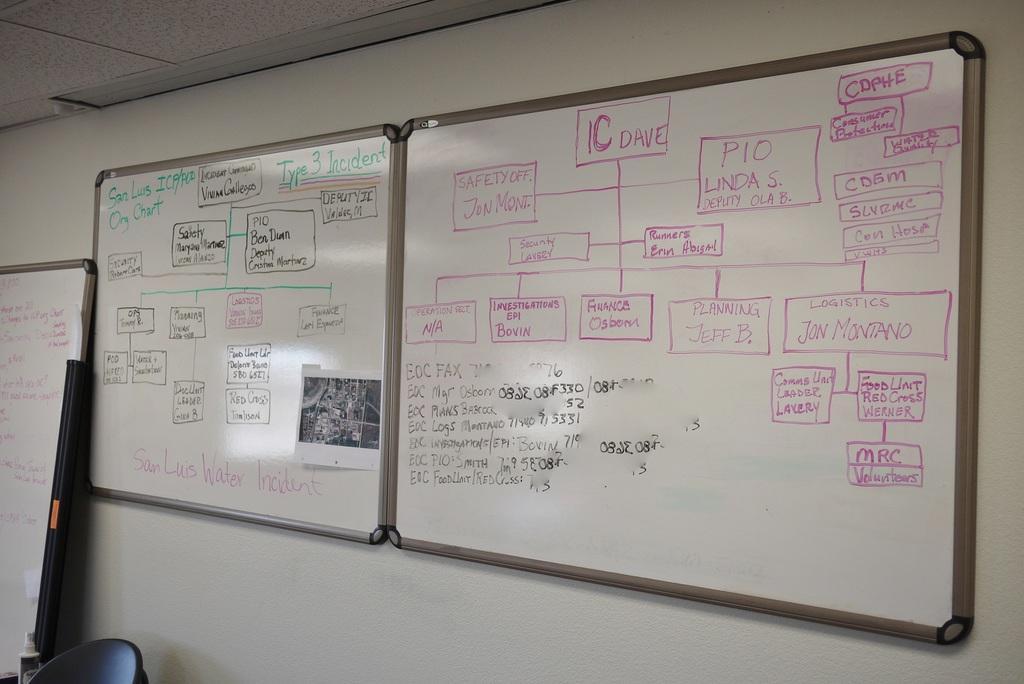In one or two sentences, can you explain what this image depicts? In this image we can see white boards attached to the wall and some text written on them. 